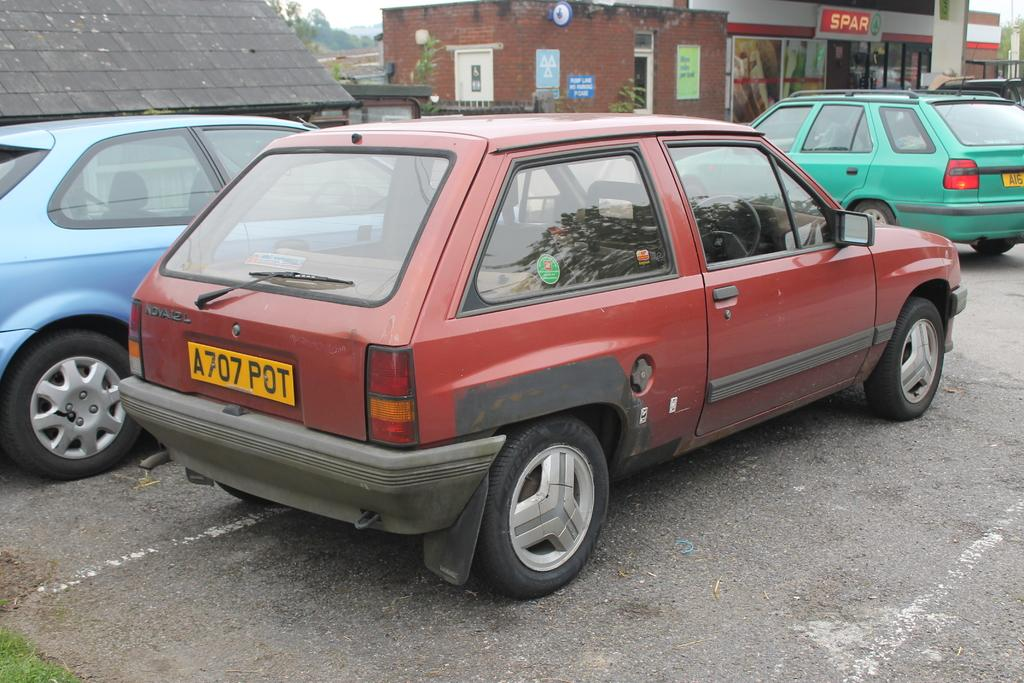What is located in the foreground of the image? There are cars in the foreground of the image. What can be seen behind the cars? There are stores visible behind the cars. What type of natural elements are present in the background of the image? There are trees in the background of the image. Can you tell me how many leather dinosaurs are sitting on the cars in the image? There are no dinosaurs, leather or otherwise, sitting on the cars in the image. 